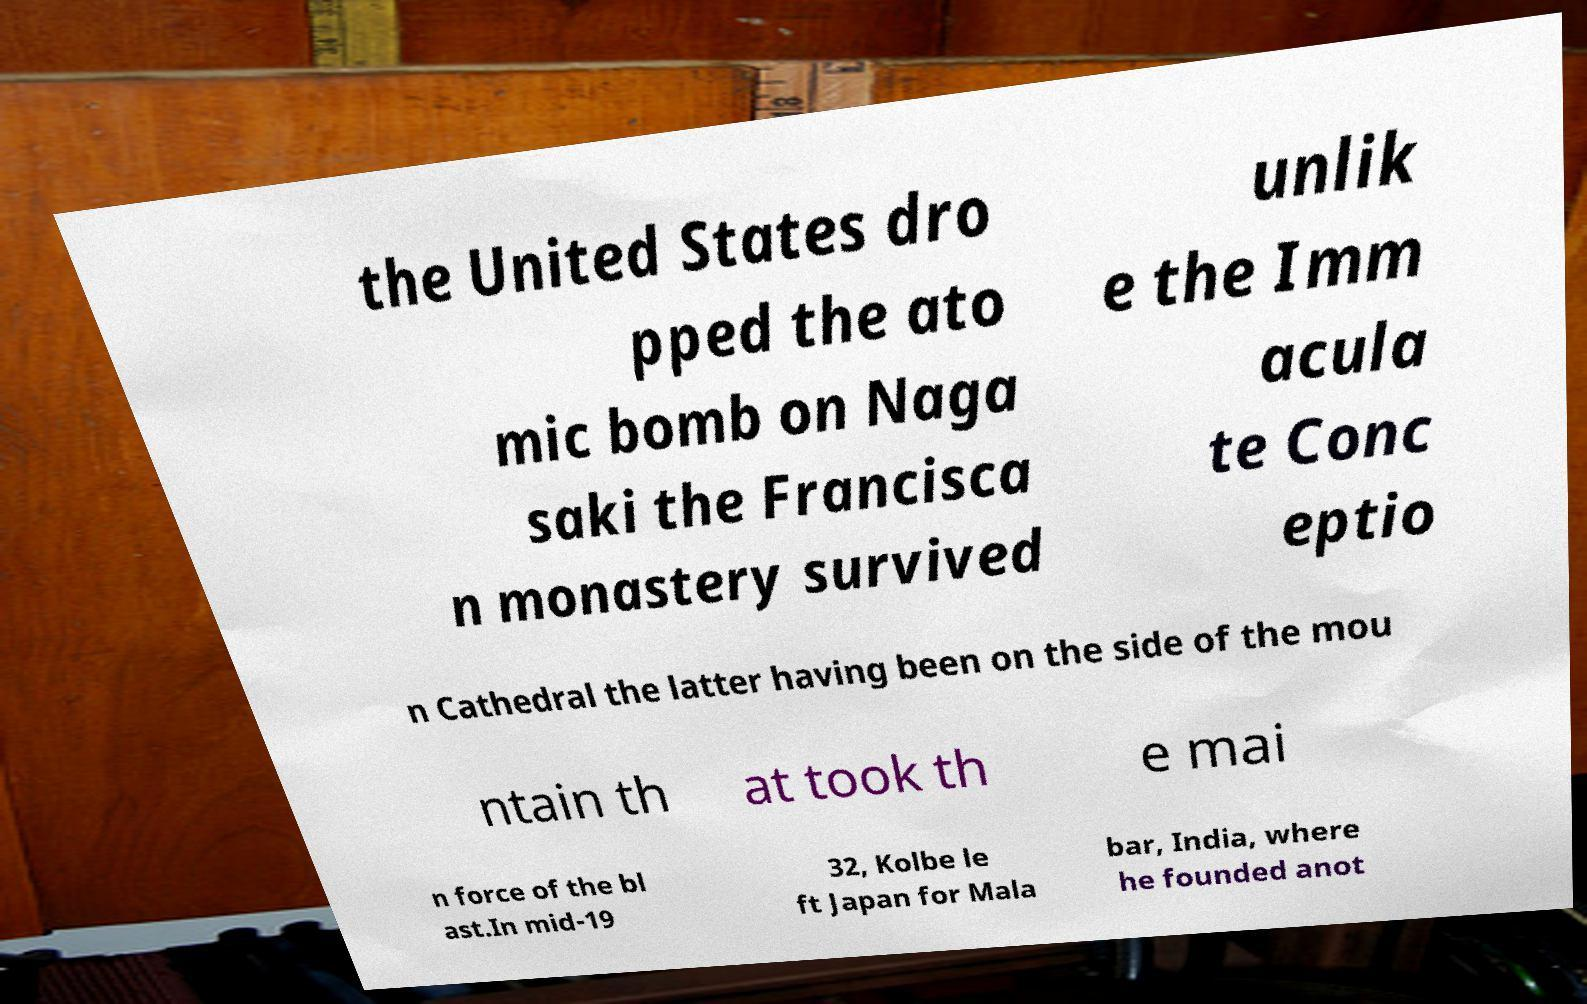Could you extract and type out the text from this image? the United States dro pped the ato mic bomb on Naga saki the Francisca n monastery survived unlik e the Imm acula te Conc eptio n Cathedral the latter having been on the side of the mou ntain th at took th e mai n force of the bl ast.In mid-19 32, Kolbe le ft Japan for Mala bar, India, where he founded anot 